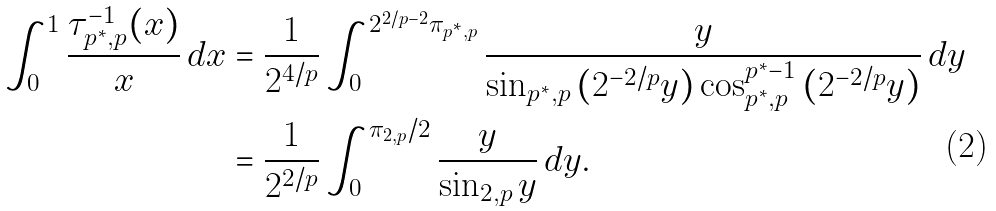Convert formula to latex. <formula><loc_0><loc_0><loc_500><loc_500>\int _ { 0 } ^ { 1 } \frac { \tau _ { p ^ { * } , p } ^ { - 1 } { ( x ) } } { x } \, d x & = \frac { 1 } { 2 ^ { 4 / p } } \int _ { 0 } ^ { 2 ^ { 2 / p - 2 } \pi _ { p ^ { * } , p } } \frac { y } { \sin _ { p ^ { * } , p } { ( 2 ^ { - 2 / p } y ) } \cos _ { p ^ { * } , p } ^ { p ^ { * } - 1 } { ( 2 ^ { - 2 / p } y ) } } \, d y \\ & = \frac { 1 } { 2 ^ { 2 / p } } \int _ { 0 } ^ { \pi _ { 2 , p } / 2 } \frac { y } { \sin _ { 2 , p } { y } } \, d y .</formula> 